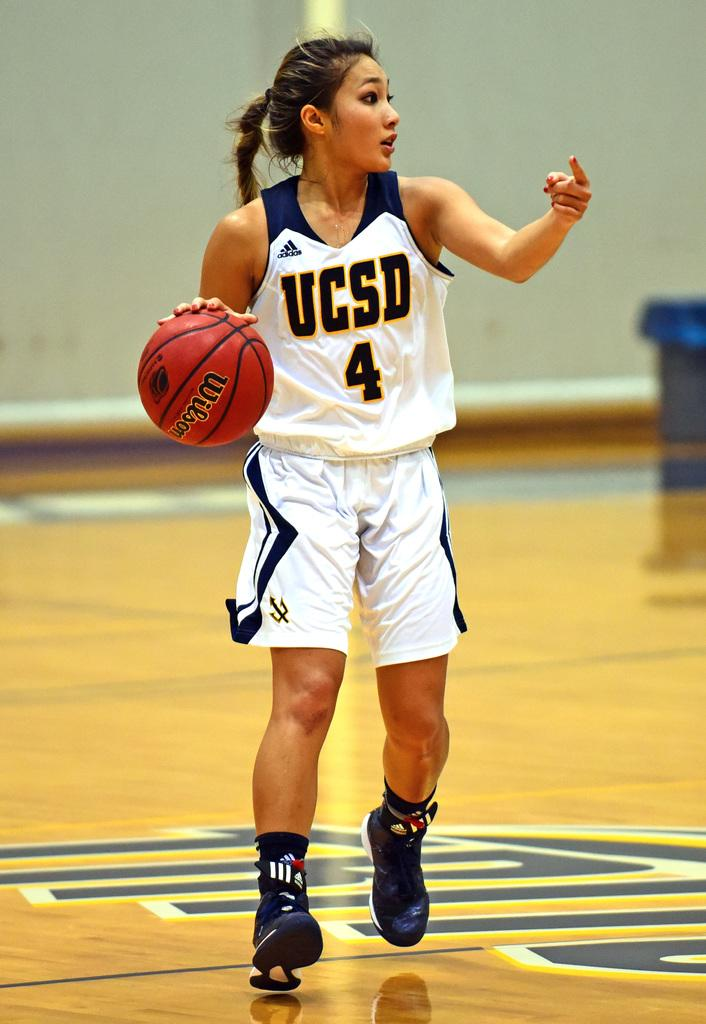<image>
Give a short and clear explanation of the subsequent image. Female basketball player dribbling a basketball while wearing a "UCSD" jersey. 